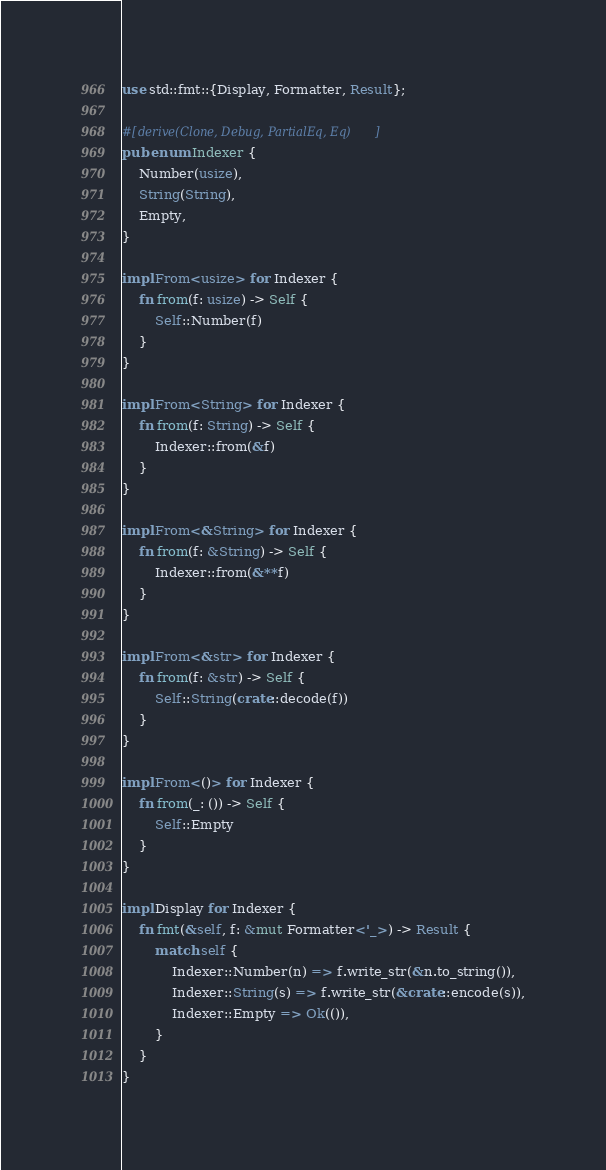<code> <loc_0><loc_0><loc_500><loc_500><_Rust_>use std::fmt::{Display, Formatter, Result};

#[derive(Clone, Debug, PartialEq, Eq)]
pub enum Indexer {
    Number(usize),
    String(String),
    Empty,
}

impl From<usize> for Indexer {
    fn from(f: usize) -> Self {
        Self::Number(f)
    }
}

impl From<String> for Indexer {
    fn from(f: String) -> Self {
        Indexer::from(&f)
    }
}

impl From<&String> for Indexer {
    fn from(f: &String) -> Self {
        Indexer::from(&**f)
    }
}

impl From<&str> for Indexer {
    fn from(f: &str) -> Self {
        Self::String(crate::decode(f))
    }
}

impl From<()> for Indexer {
    fn from(_: ()) -> Self {
        Self::Empty
    }
}

impl Display for Indexer {
    fn fmt(&self, f: &mut Formatter<'_>) -> Result {
        match self {
            Indexer::Number(n) => f.write_str(&n.to_string()),
            Indexer::String(s) => f.write_str(&crate::encode(s)),
            Indexer::Empty => Ok(()),
        }
    }
}
</code> 